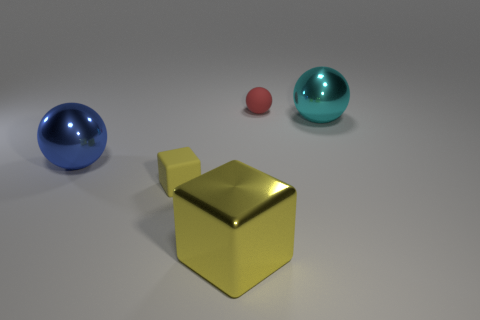Subtract 1 balls. How many balls are left? 2 Add 4 large cyan shiny balls. How many objects exist? 9 Subtract all cubes. How many objects are left? 3 Subtract 0 brown cylinders. How many objects are left? 5 Subtract all blocks. Subtract all small blue metallic cylinders. How many objects are left? 3 Add 4 yellow things. How many yellow things are left? 6 Add 1 big red rubber spheres. How many big red rubber spheres exist? 1 